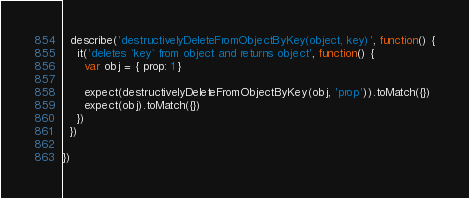Convert code to text. <code><loc_0><loc_0><loc_500><loc_500><_JavaScript_>
  describe('destructivelyDeleteFromObjectByKey(object, key)', function() {
    it('deletes `key` from object and returns object', function() {
      var obj = { prop: 1 }

      expect(destructivelyDeleteFromObjectByKey(obj, 'prop')).toMatch({})
      expect(obj).toMatch({})
    })
  })

})
</code> 